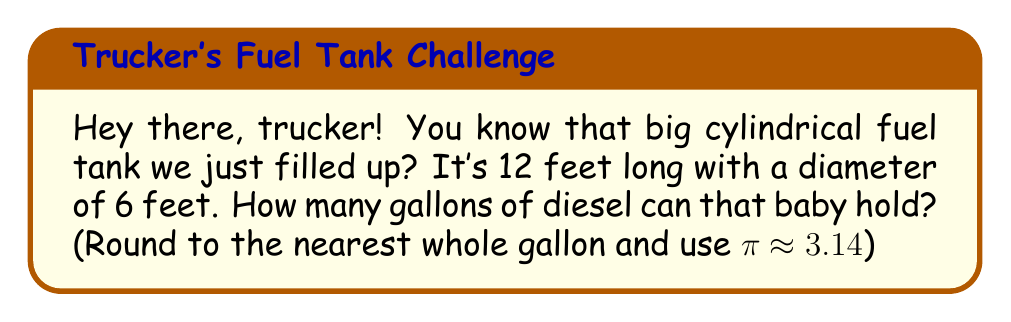Can you answer this question? Alright, let's break this down step-by-step:

1) First, we need to find the volume of the cylindrical tank. The formula for the volume of a cylinder is:
   
   $$V = \pi r^2 h$$
   
   where $r$ is the radius and $h$ is the height (or length in this case).

2) We're given the diameter (6 feet), so we need to halve that to get the radius:
   
   $$r = 6 \div 2 = 3 \text{ feet}$$

3) Now, let's plug our values into the formula:
   
   $$V = 3.14 \times 3^2 \times 12$$

4) Let's calculate:
   
   $$V = 3.14 \times 9 \times 12 = 339.12 \text{ cubic feet}$$

5) But we need gallons, not cubic feet. There are approximately 7.48052 gallons in a cubic foot. So:
   
   $$339.12 \times 7.48052 \approx 2536.73 \text{ gallons}$$

6) Rounding to the nearest whole gallon:
   
   $$2536.73 \approx 2537 \text{ gallons}$$
Answer: 2537 gallons 